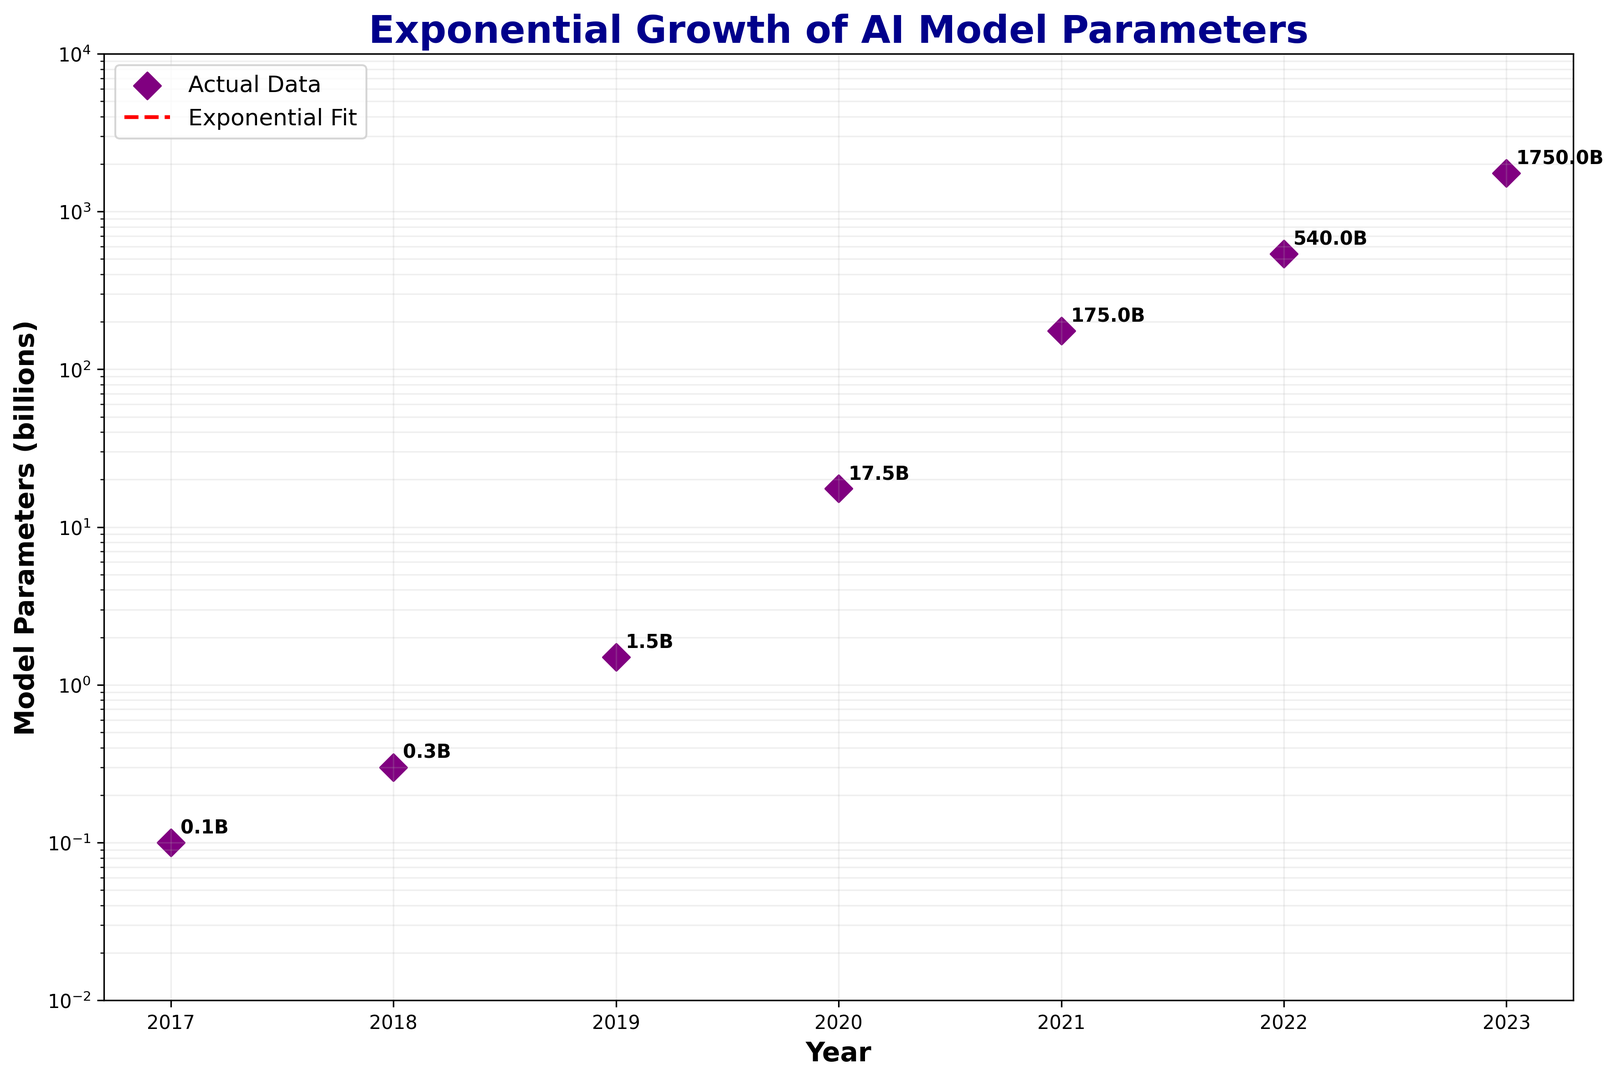What is the parameter value for the year 2020? You can see that the parameter value for 2020 is indicated by a purple diamond symbol with the annotation "17.5B" next to it.
Answer: 17.5 billion What's the difference in model parameters between 2021 and 2017? The parameter value in 2021 is 175 billion, and in 2017 it is 0.1 billion. The difference is calculated by subtracting the 2017 value from the 2021 value: 175 - 0.1 = 174.9 billion.
Answer: 174.9 billion Which year showed the highest increase in model parameters compared to the previous year? By examining the data points, we see the largest increase is from 2022 to 2023, from 540 billion to 1750 billion. The increase is 1750 - 540 = 1210 billion, which is the highest compared to other year intervals.
Answer: 2023 How does the exponential fit line help us understand the trend in model parameters? The red dashed exponential fit line visually indicates that the model growth follows an exponential trend, meaning the increase accelerates over time rather than being linear or constant. This helps illustrate the rapid and compounding growth in model parameters.
Answer: It shows rapid, accelerating growth What’s the average annual growth rate of model parameters between 2019 and 2021? The parameter values in 2019, 2020, and 2021 are 1.5 billion, 17.5 billion, and 175 billion, respectively. Growth from 2019 to 2020 is (17.5 - 1.5) / 1.5 * 100% = 1066.67%, and from 2020 to 2021 is (175 - 17.5) / 17.5 * 100% = 900%. Average annual growth rate is (1066.67% + 900%) / 2 = 983.34%.
Answer: 983.34% Do the model parameters grow faster than the exponential fit in any given year? The actual data points (purple diamonds) mostly lie above the exponential fit line, indicating that the parameters grow faster than the fit line suggests for most years, especially in 2020, 2021, and 2022.
Answer: Yes What visual cue is used to highlight the data points of model parameters? The data points are highlighted using large purple diamond markers for each year, which are annotated with the specific parameter values in billions.
Answer: Purple diamond markers 